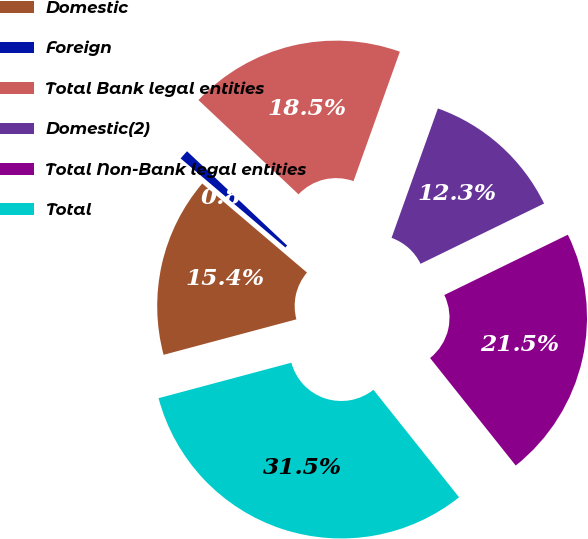Convert chart. <chart><loc_0><loc_0><loc_500><loc_500><pie_chart><fcel>Domestic<fcel>Foreign<fcel>Total Bank legal entities<fcel>Domestic(2)<fcel>Total Non-Bank legal entities<fcel>Total<nl><fcel>15.37%<fcel>0.81%<fcel>18.45%<fcel>12.3%<fcel>21.52%<fcel>31.55%<nl></chart> 